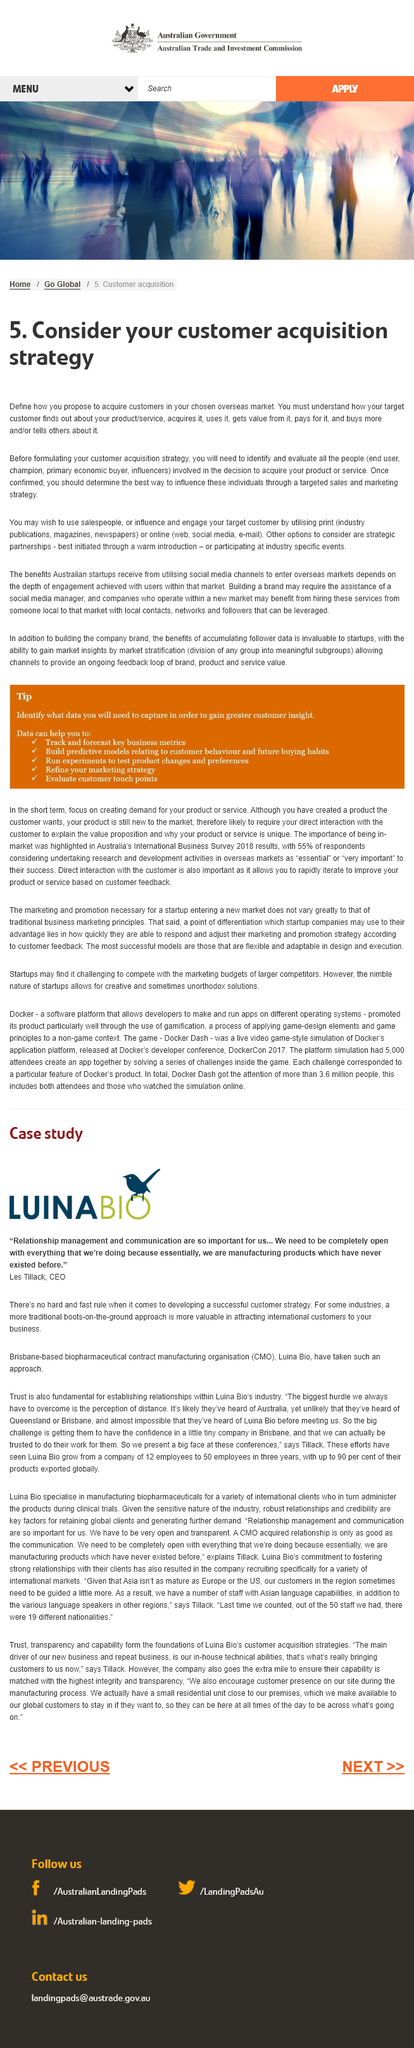Point out several critical features in this image. Yes, salespeople may be utilized by someone. Yes, strategic partnerships are another option that should be considered. The fact that acquiring customers in an overseas market is an essential element of a customer acquisition strategy is undeniable. 